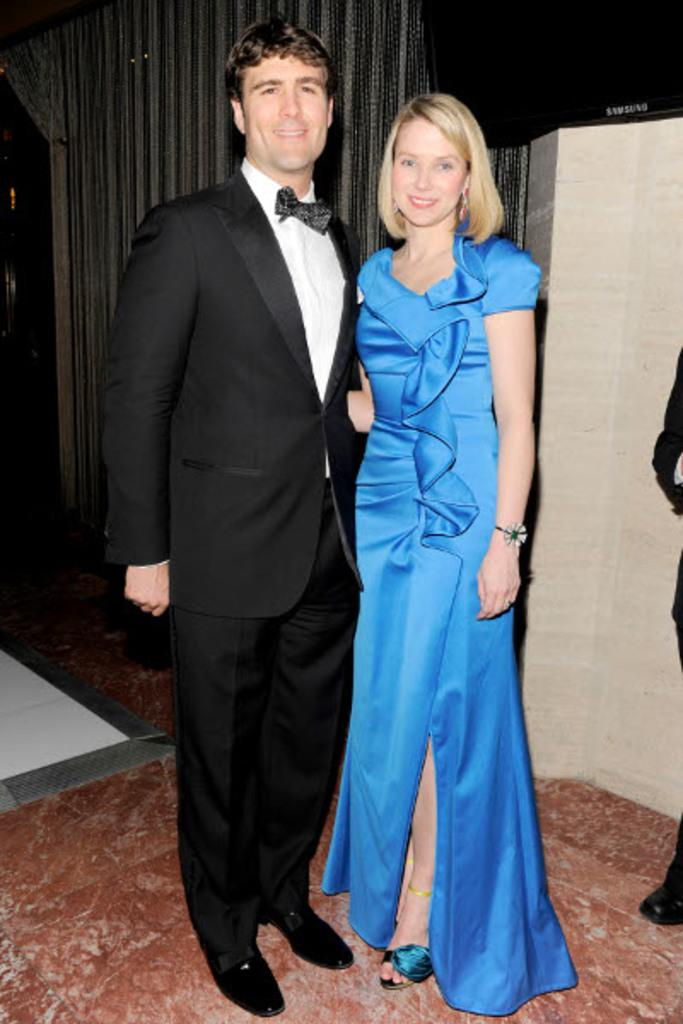How many people are present in the image? There are two people, a man and a woman, present in the image. What are the positions of the man and the woman in the image? Both the man and the woman are standing in the image. What can be seen in the background of the image? There are curtains and a wall in the background of the image. What type of mine can be seen in the image? There is no mine present in the image; it features a man and a woman standing in front of a wall and curtains. 